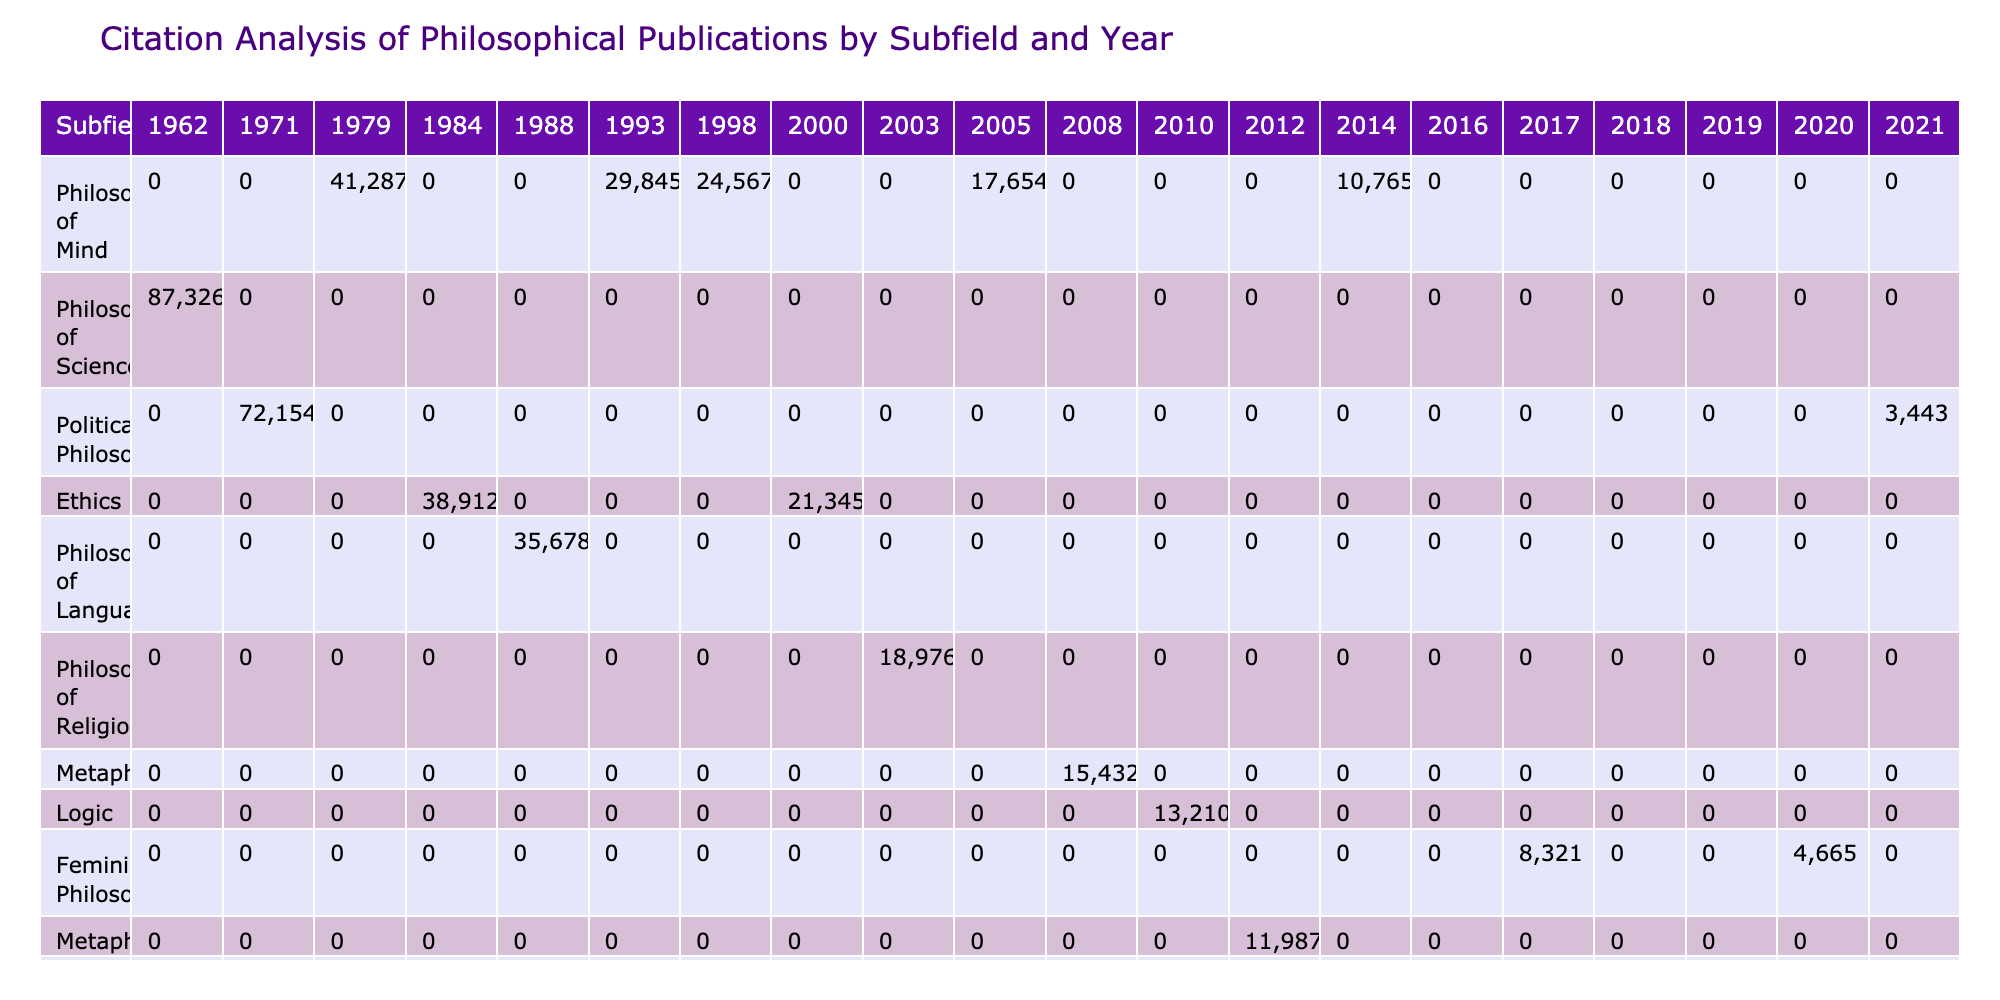What is the total number of citations for the publication "A Theory of Justice"? Looking at the table, "A Theory of Justice" is listed under the subfield "Political Philosophy" for the year 1971 with a total of 72,154 citations.
Answer: 72154 Which subfield has the highest total citations in the year 2010? In the year 2010, the only publication listed is "In Contradiction" by Graham Priest in the subfield of Logic, which has 13,210 citations. Since it’s the only entry for that year in the table, it's also the highest.
Answer: Logic How many citations does "Naming and Necessity" have compared to "Reasons and Persons"? "Naming and Necessity" has 35,678 citations and "Reasons and Persons" has 38,912 citations. To find the difference, subtract: 38,912 - 35,678 = 3,234.
Answer: 3234 Did "Dark Ghettos: Injustice Dissent and Reform" receive more citations than "The Right to Sex"? "Dark Ghettos: Injustice Dissent and Reform" has 7,109 citations and "The Right to Sex" has 4,665 citations. Since 7,109 is greater than 4,665, the statement is true.
Answer: Yes Which philosophical subfield received the least citations in the year 2021? In the table, the only publication for 2021 is "Reconsidering Reparations" by Olúfẹ́mi O. Táíwò in Political Philosophy with 3,443 citations, indicating it's the least for that year. No other entries for 2021 are present in the table.
Answer: Political Philosophy What is the average number of citations for the subfield Philosophy of Mind? The three publications in the Philosophy of Mind subfield have 41,287, 29,845, and 24,567 citations. Summing them up gives: 41,287 + 29,845 + 24,567 = 95,699. There are three publications, so the average is 95,699 / 3 ≈ 31,899.67.
Answer: 31899.67 Which author in the Ethics subfield has the most citations? The Ethics subfield features "Reasons and Persons" by Derek Parfit with 38,912 citations and "Writings on an Ethical Life" by Peter Singer with 21,345 citations. Since 38,912 is more than 21,345, Derek Parfit has the most citations.
Answer: Derek Parfit Which subfield has the maximum citations across all years? By examining the table, the Philosophy of Mind subfield has the highest individual citations: 41,287 (Douglas Hofstadter), 29,845 (Daniel Dennett), 24,567 (John Searle), and 17,654 (David Chalmers). Summing these gives 41,287 + 29,845 + 24,567 + 17,654 = 113,353 citations, which is higher than any other subfield total.
Answer: Philosophy of Mind In what year did "Mind and Cosmos" achieve its citations? "Mind and Cosmos" by Thomas Nagel was published in 2014 and received 10,765 citations as stated in the table. The year listed provides the date of publication along with the associated citation count.
Answer: 2014 